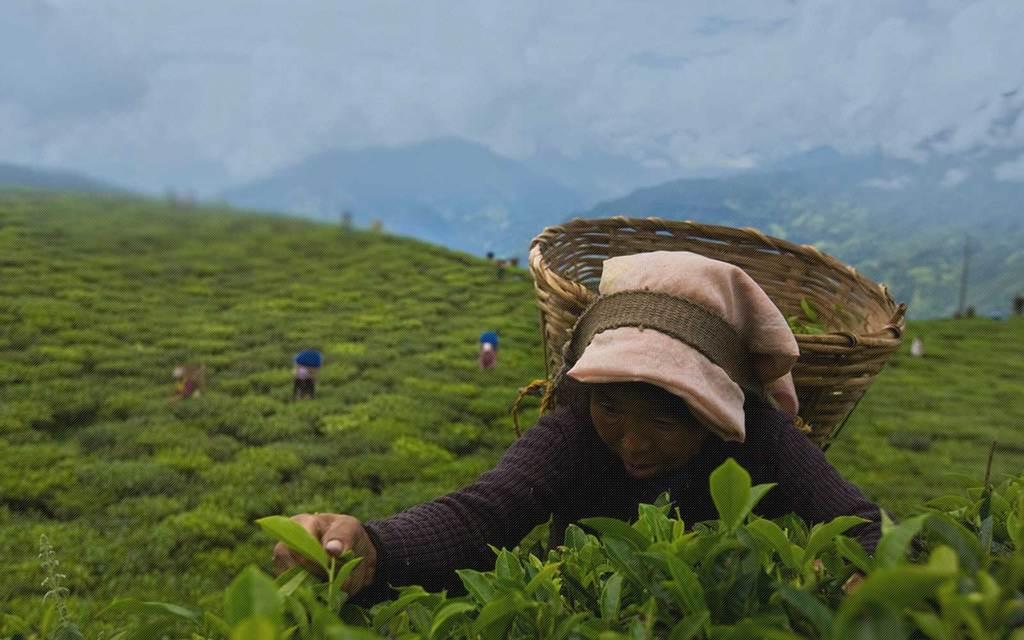Who can be seen in the image? There are people in the image. What is the woman in the image carrying? The woman in the image has a basket. What can be seen in the distance in the image? There are trees, hills, and the sky visible in the background of the image. What type of crime is being committed in the image? There is no crime being committed in the image; it features people, a woman with a basket, and a background with trees, hills, and the sky. 